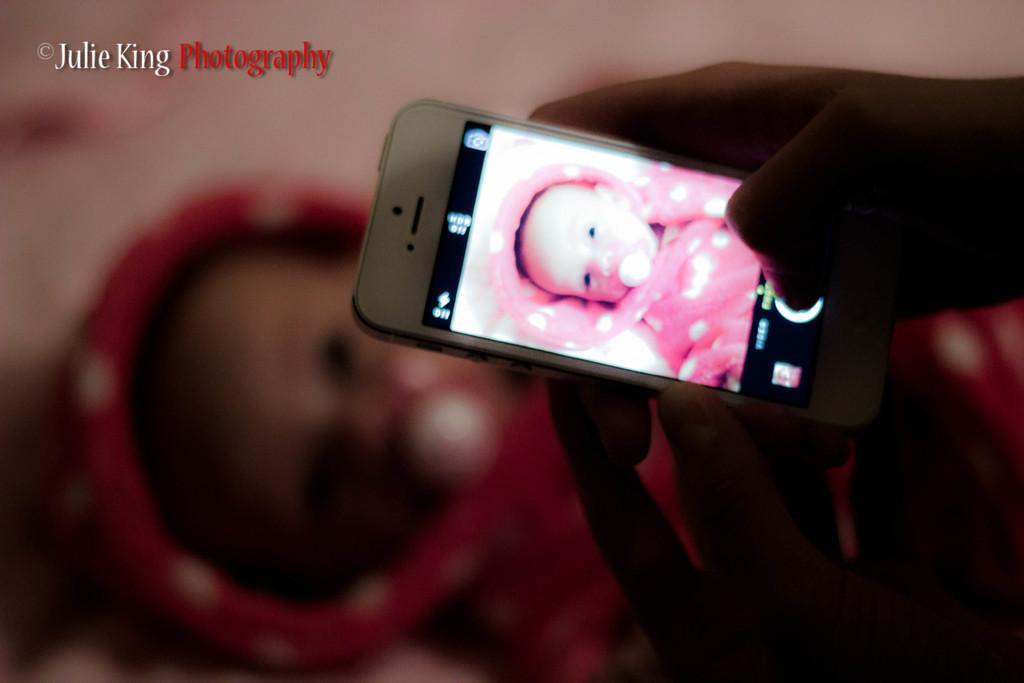How would you summarize this image in a sentence or two? In the foreground of the picture we can see a person holding a mobile, in the mobile there is a picture of a kid. The background is blurred. 